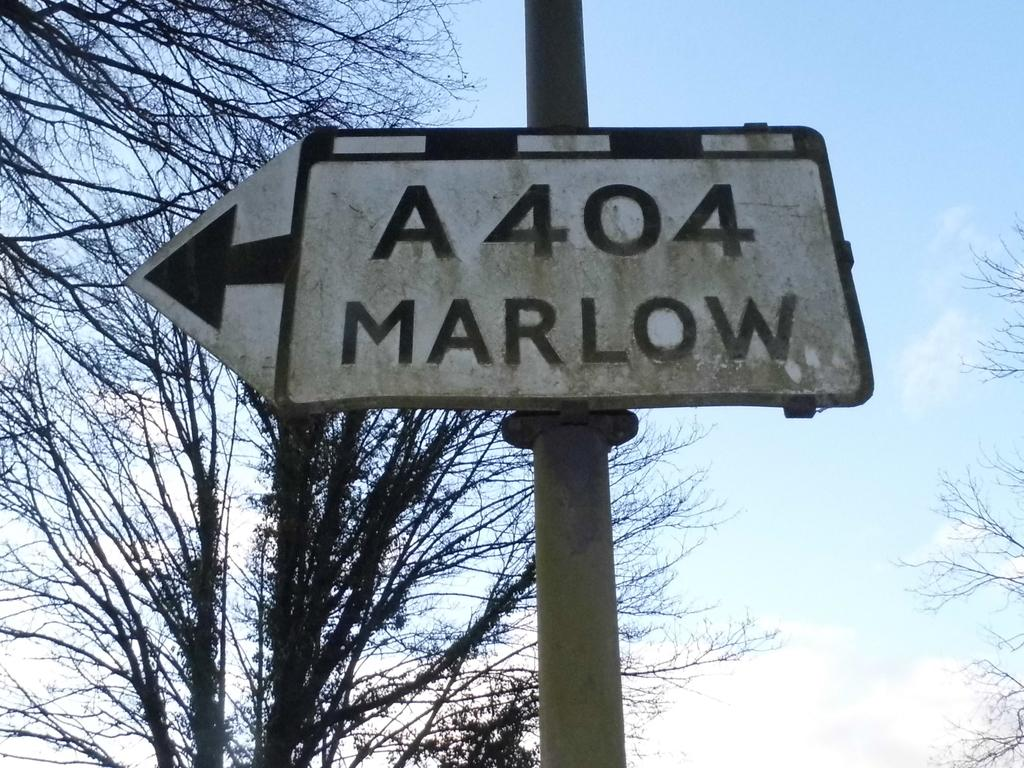What is located in the middle of the image? There is a pole in the middle of the image. What is attached to the pole? There is a sign board on the pole. What can be seen behind the pole? There are trees visible behind the pole. What is visible in the sky in the image? There are clouds in the sky, and the sky is visible in the image. What type of sail can be seen on the animal in the image? There is no animal or sail present in the image; it features a pole with a sign board and trees in the background. 